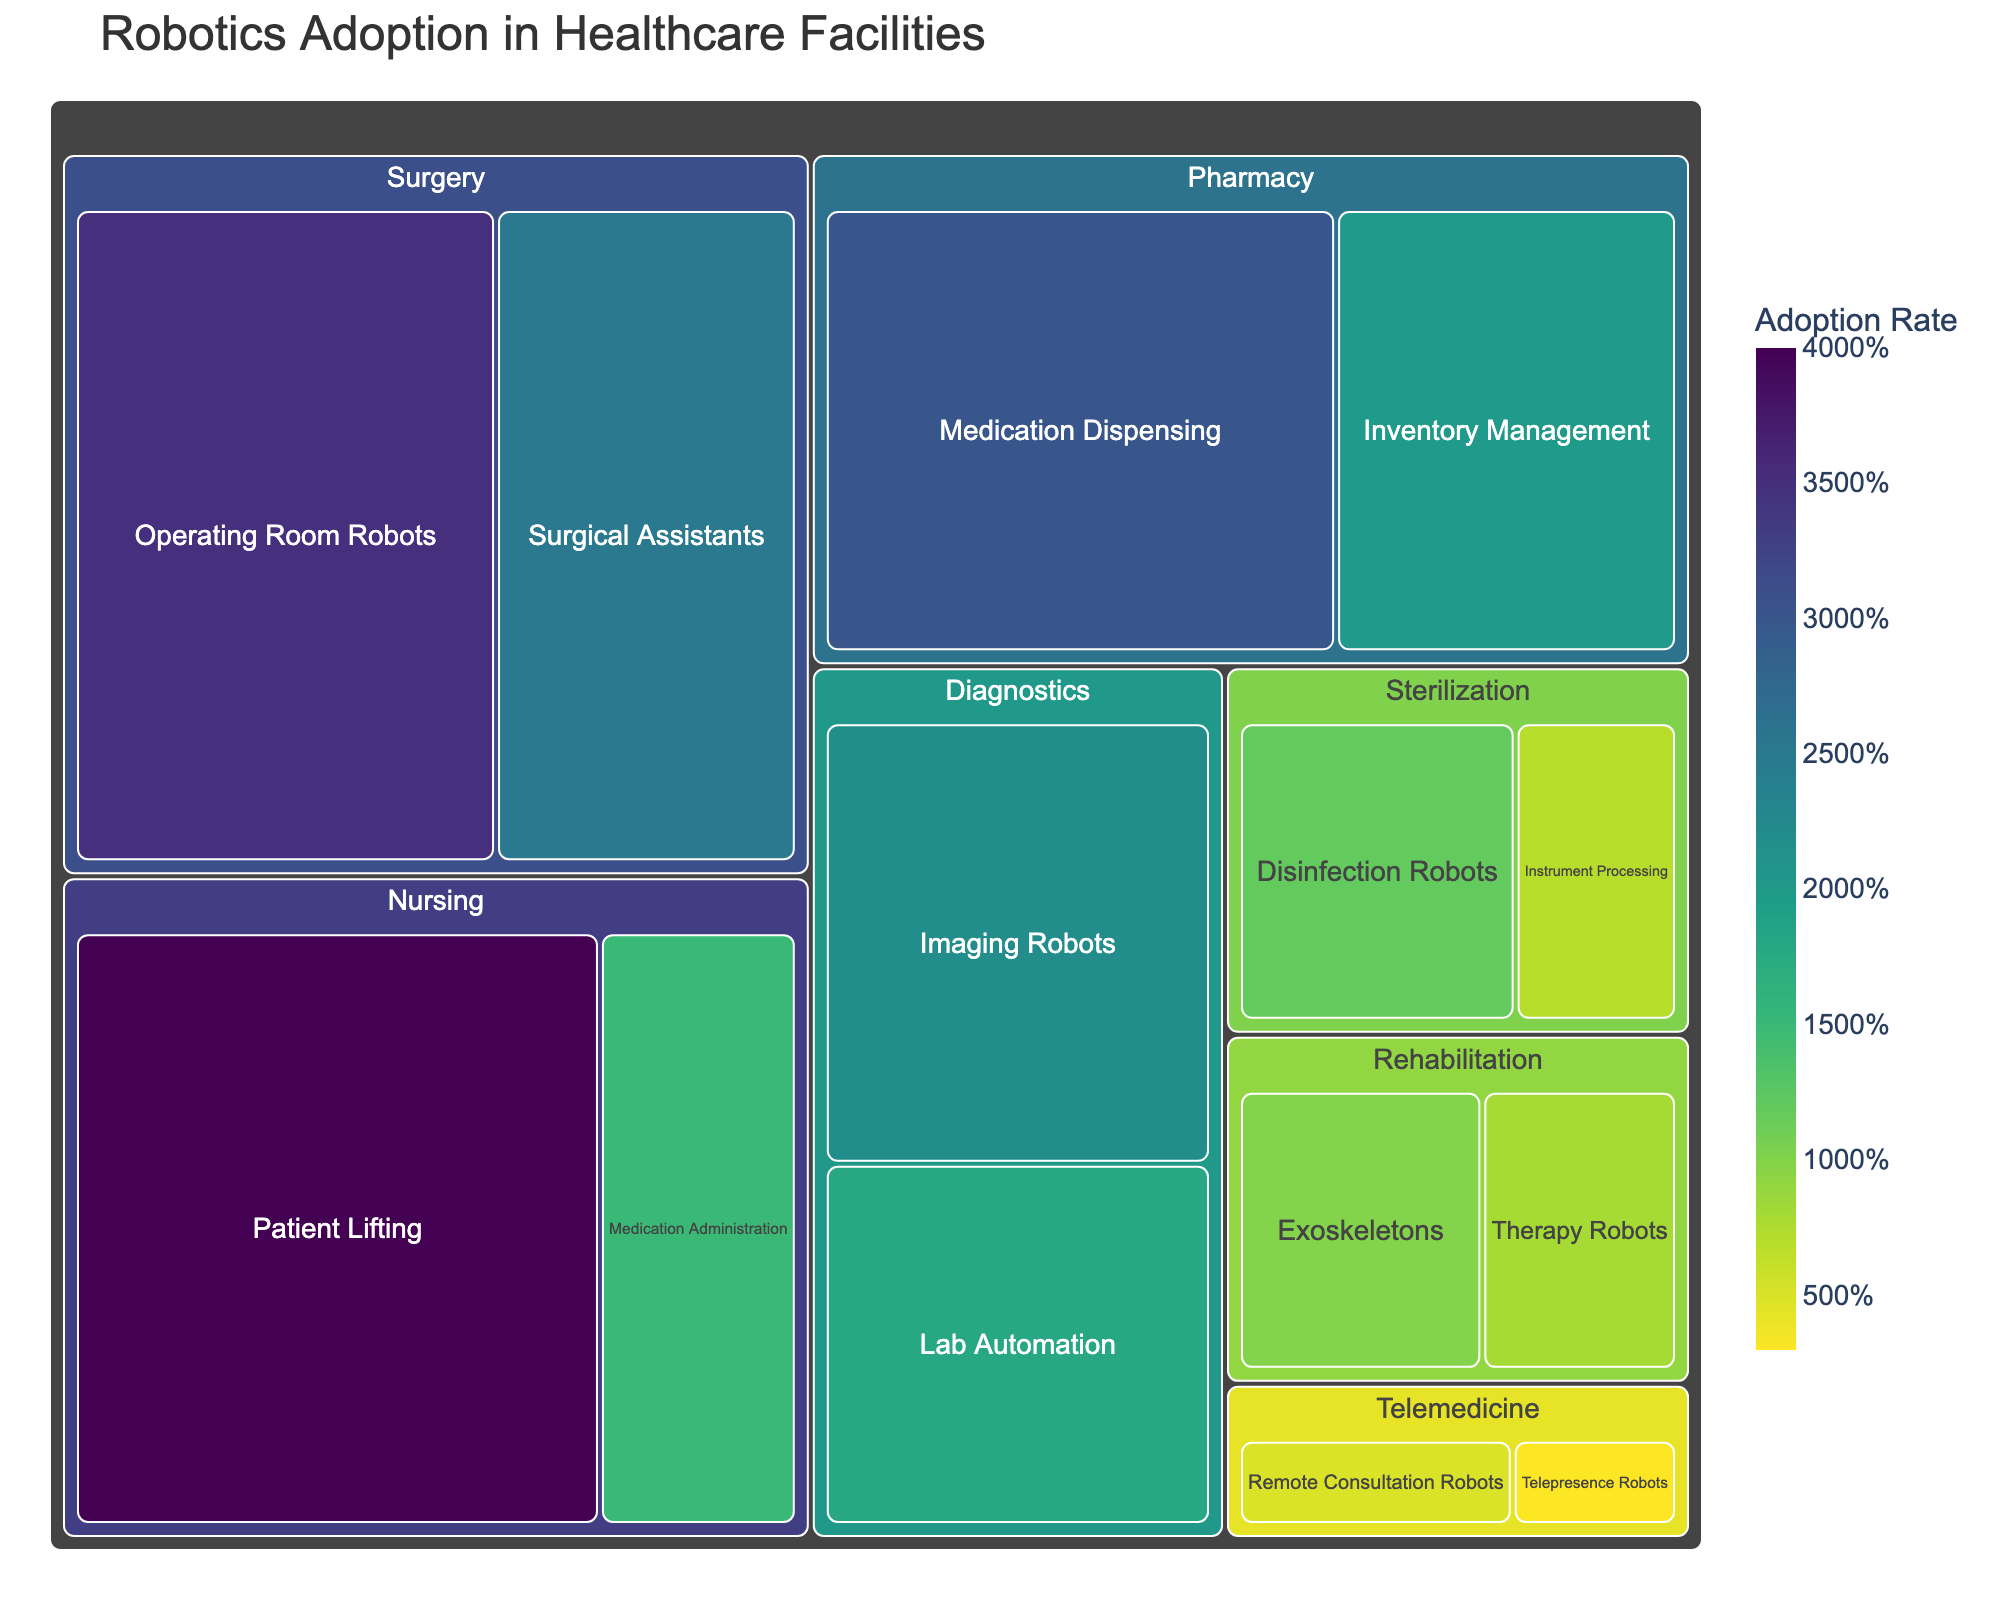How many departments are shown in the treemap? The treemap has a hierarchical structure, with departments as the main categories. You can count the number of distinct departments directly.
Answer: 6 Which department has the highest adoption rate for any of its categories? Look for the highest single value across all categories within the departments. The highest value is in the Nursing department with Patient Lifting having an adoption rate of 40.
Answer: Nursing What is the total adoption rate of all categories in the Pharmacy department? Sum the adoption rates of all categories under the Pharmacy department. Medication Dispensing is 30 and Inventory Management is 20, so 30 + 20 = 50.
Answer: 50 Which two categories have the closest adoption rates, and what are they? Compare the adoption rates and find the smallest difference between two categories. The two categories with the closest adoption rates are Lab Automation (18) and Instrument Processing (7) with a difference of 1.
Answer: Diagnostics (Lab Automation) and Sterilization (Instrument Processing) What percentage of the total adoption rate does the Surgery department contribute? Calculate the total adoption rate for all categories. Then, calculate the Surgery department's contribution as a percentage of the total. Surgery department (35 + 25 = 60), Total (35 + 25 + 30 + 20 + 40 + 15 + 10 + 8 + 22 + 18 + 12 + 7 + 5 + 3 = 250). Surgery contributes 60/250 * 100 = 24%.
Answer: 24% Which category has the lowest adoption rate within the Telemedicine department? Compare the adoption rates for all categories under Telemedicine. Remote Consultation Robots is 5 and Telepresence Robots is 3, so the lowest is 3.
Answer: Telepresence Robots If we combine the adoption rates of all diagnostic categories, what will it be? Sum the adoption rates of Imaging Robots and Lab Automation under Diagnostics. Imaging Robots is 22 and Lab Automation is 18, so 22 + 18 = 40.
Answer: 40 Compare the total adoption rates between the Surgical and Sterilization departments. Which is higher? Sum the adoption rates for all categories in Surgery (35 + 25 = 60) and Sterilization (12 + 7 = 19). The Surgery department has a higher adoption rate of 60 compared to 19 in Sterilization.
Answer: Surgery What is the average adoption rate of the categories under the Nursing department? Sum the adoption rates for all categories in Nursing and divide by the number of categories. Patient Lifting is 40 and Medication Administration is 15, so (40 + 15)/2 = 27.5.
Answer: 27.5 